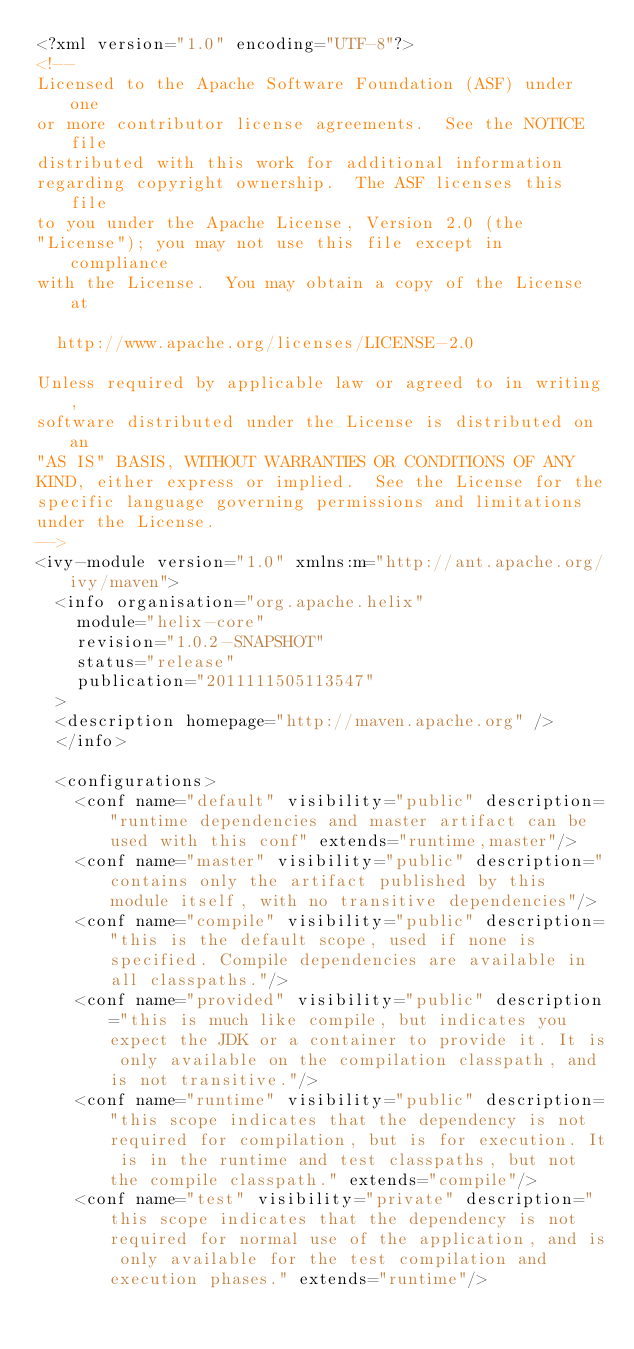<code> <loc_0><loc_0><loc_500><loc_500><_XML_><?xml version="1.0" encoding="UTF-8"?>
<!--
Licensed to the Apache Software Foundation (ASF) under one
or more contributor license agreements.  See the NOTICE file
distributed with this work for additional information
regarding copyright ownership.  The ASF licenses this file
to you under the Apache License, Version 2.0 (the
"License"); you may not use this file except in compliance
with the License.  You may obtain a copy of the License at

  http://www.apache.org/licenses/LICENSE-2.0

Unless required by applicable law or agreed to in writing,
software distributed under the License is distributed on an
"AS IS" BASIS, WITHOUT WARRANTIES OR CONDITIONS OF ANY
KIND, either express or implied.  See the License for the
specific language governing permissions and limitations
under the License.
-->
<ivy-module version="1.0" xmlns:m="http://ant.apache.org/ivy/maven">
	<info organisation="org.apache.helix"
		module="helix-core"
		revision="1.0.2-SNAPSHOT"
		status="release"
		publication="2011111505113547"
	>
	<description homepage="http://maven.apache.org" />
	</info>

	<configurations>
		<conf name="default" visibility="public" description="runtime dependencies and master artifact can be used with this conf" extends="runtime,master"/>
		<conf name="master" visibility="public" description="contains only the artifact published by this module itself, with no transitive dependencies"/>
		<conf name="compile" visibility="public" description="this is the default scope, used if none is specified. Compile dependencies are available in all classpaths."/>
		<conf name="provided" visibility="public" description="this is much like compile, but indicates you expect the JDK or a container to provide it. It is only available on the compilation classpath, and is not transitive."/>
		<conf name="runtime" visibility="public" description="this scope indicates that the dependency is not required for compilation, but is for execution. It is in the runtime and test classpaths, but not the compile classpath." extends="compile"/>
		<conf name="test" visibility="private" description="this scope indicates that the dependency is not required for normal use of the application, and is only available for the test compilation and execution phases." extends="runtime"/></code> 